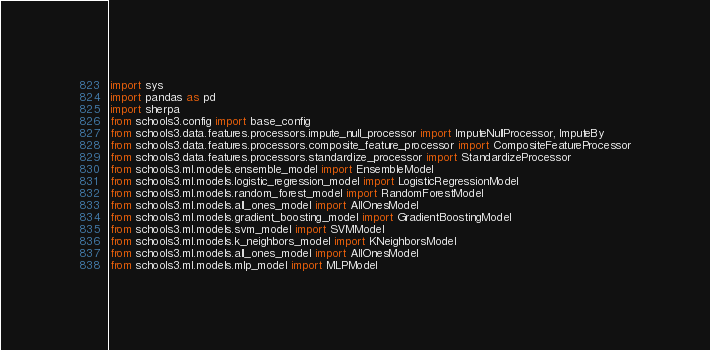Convert code to text. <code><loc_0><loc_0><loc_500><loc_500><_Python_>import sys
import pandas as pd
import sherpa
from schools3.config import base_config
from schools3.data.features.processors.impute_null_processor import ImputeNullProcessor, ImputeBy
from schools3.data.features.processors.composite_feature_processor import CompositeFeatureProcessor
from schools3.data.features.processors.standardize_processor import StandardizeProcessor
from schools3.ml.models.ensemble_model import EnsembleModel
from schools3.ml.models.logistic_regression_model import LogisticRegressionModel
from schools3.ml.models.random_forest_model import RandomForestModel
from schools3.ml.models.all_ones_model import AllOnesModel
from schools3.ml.models.gradient_boosting_model import GradientBoostingModel
from schools3.ml.models.svm_model import SVMModel
from schools3.ml.models.k_neighbors_model import KNeighborsModel
from schools3.ml.models.all_ones_model import AllOnesModel
from schools3.ml.models.mlp_model import MLPModel</code> 